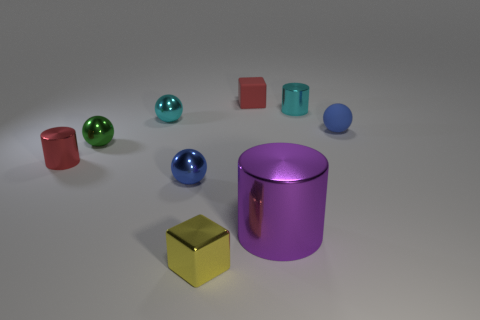Is the shape of the small red thing that is right of the red shiny cylinder the same as  the green object?
Your answer should be compact. No. How many small blue things are to the left of the tiny red matte block and to the right of the red block?
Your answer should be compact. 0. There is a small metallic sphere in front of the red shiny object left of the tiny shiny object that is on the right side of the large thing; what is its color?
Make the answer very short. Blue. How many red cubes are in front of the tiny metallic sphere behind the blue matte object?
Your answer should be very brief. 0. How many other objects are the same shape as the tiny green object?
Provide a succinct answer. 3. What number of things are tiny rubber cubes or tiny things behind the yellow metallic object?
Provide a succinct answer. 7. Is the number of large purple things that are behind the red cube greater than the number of large purple metal cylinders that are in front of the big purple cylinder?
Provide a short and direct response. No. What is the shape of the small red thing behind the small blue ball that is on the right side of the small red object right of the tiny shiny block?
Your answer should be very brief. Cube. There is a tiny yellow object in front of the tiny blue shiny ball behind the large cylinder; what is its shape?
Offer a very short reply. Cube. Are there any cyan things made of the same material as the red cylinder?
Give a very brief answer. Yes. 